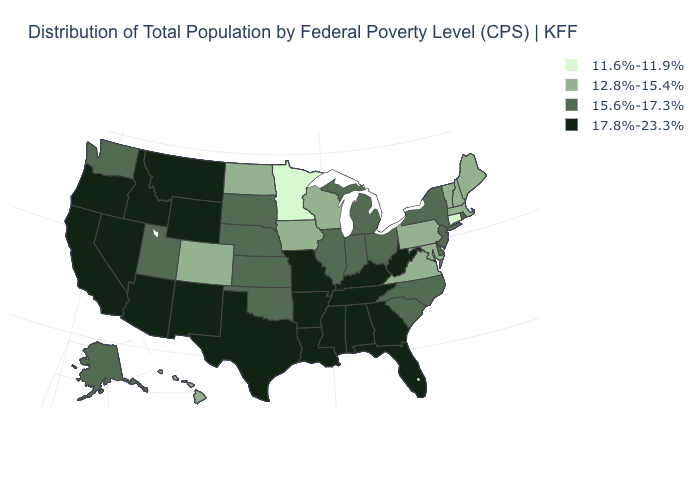Name the states that have a value in the range 12.8%-15.4%?
Give a very brief answer. Colorado, Hawaii, Iowa, Maine, Maryland, Massachusetts, New Hampshire, North Dakota, Pennsylvania, Vermont, Virginia, Wisconsin. Is the legend a continuous bar?
Short answer required. No. What is the value of Alaska?
Short answer required. 15.6%-17.3%. Name the states that have a value in the range 12.8%-15.4%?
Be succinct. Colorado, Hawaii, Iowa, Maine, Maryland, Massachusetts, New Hampshire, North Dakota, Pennsylvania, Vermont, Virginia, Wisconsin. What is the value of Iowa?
Give a very brief answer. 12.8%-15.4%. Name the states that have a value in the range 15.6%-17.3%?
Concise answer only. Alaska, Delaware, Illinois, Indiana, Kansas, Michigan, Nebraska, New Jersey, New York, North Carolina, Ohio, Oklahoma, Rhode Island, South Carolina, South Dakota, Utah, Washington. Does the map have missing data?
Answer briefly. No. What is the highest value in the MidWest ?
Answer briefly. 17.8%-23.3%. What is the value of Connecticut?
Answer briefly. 11.6%-11.9%. Name the states that have a value in the range 11.6%-11.9%?
Quick response, please. Connecticut, Minnesota. Among the states that border Florida , which have the highest value?
Short answer required. Alabama, Georgia. Name the states that have a value in the range 11.6%-11.9%?
Give a very brief answer. Connecticut, Minnesota. What is the lowest value in the West?
Be succinct. 12.8%-15.4%. Name the states that have a value in the range 11.6%-11.9%?
Give a very brief answer. Connecticut, Minnesota. Name the states that have a value in the range 15.6%-17.3%?
Be succinct. Alaska, Delaware, Illinois, Indiana, Kansas, Michigan, Nebraska, New Jersey, New York, North Carolina, Ohio, Oklahoma, Rhode Island, South Carolina, South Dakota, Utah, Washington. 